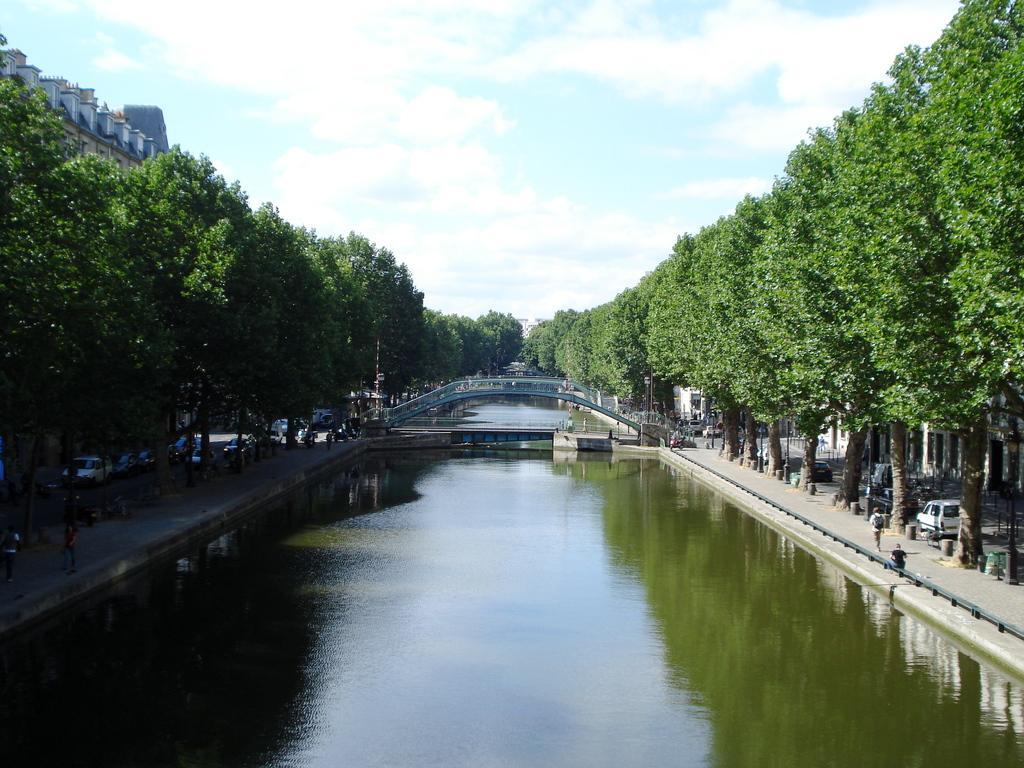Could you give a brief overview of what you see in this image? At the bottom of the picture, we see water and this water might be in the canal. In the middle of the picture, we see the bridge. On either side of the picture, there are trees and vehicles are parked. Beside that, we see people walking on the road. There are trees and buildings in the background. On the left side, we see a building. At the top of the picture, we see the sky and the clouds. 